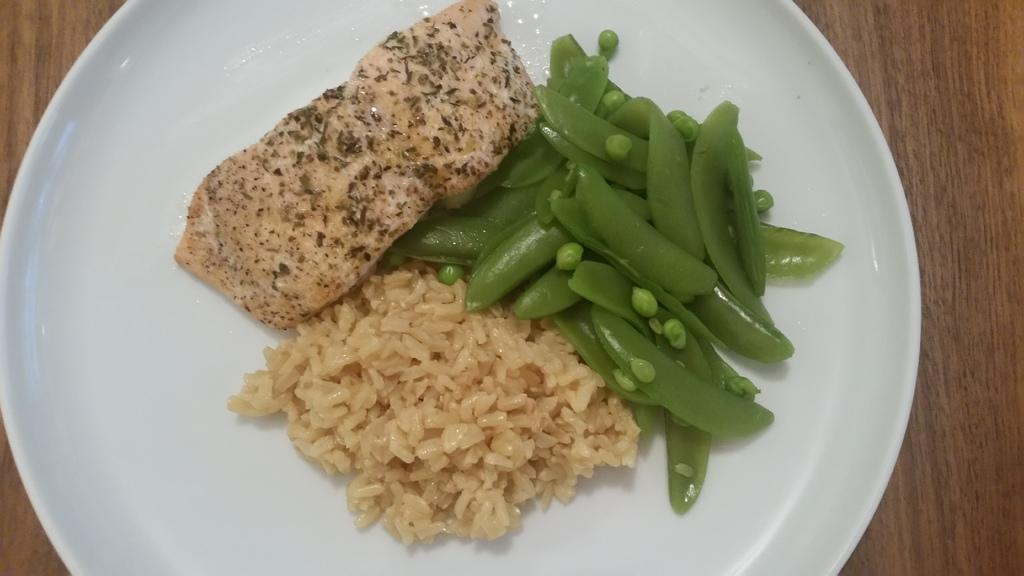What is on the plate that is visible in the image? There is food on a plate in the image. Can you describe the food on the plate? The food is eatable. What color is the plate? The plate is white. What type of surface is the plate placed on? The plate is placed on a wooden surface. Is there a beggar asking for a reward in the image? There is no beggar or mention of a reward in the image; it only shows a plate of food on a white plate placed on a wooden surface. 